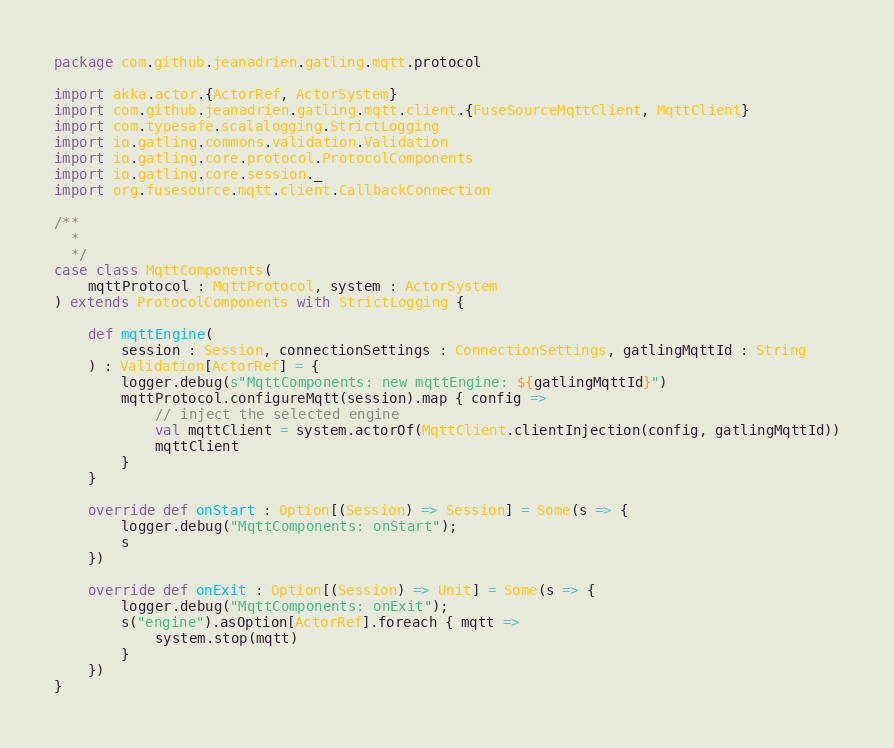<code> <loc_0><loc_0><loc_500><loc_500><_Scala_>package com.github.jeanadrien.gatling.mqtt.protocol

import akka.actor.{ActorRef, ActorSystem}
import com.github.jeanadrien.gatling.mqtt.client.{FuseSourceMqttClient, MqttClient}
import com.typesafe.scalalogging.StrictLogging
import io.gatling.commons.validation.Validation
import io.gatling.core.protocol.ProtocolComponents
import io.gatling.core.session._
import org.fusesource.mqtt.client.CallbackConnection

/**
  *
  */
case class MqttComponents(
    mqttProtocol : MqttProtocol, system : ActorSystem
) extends ProtocolComponents with StrictLogging {

    def mqttEngine(
        session : Session, connectionSettings : ConnectionSettings, gatlingMqttId : String
    ) : Validation[ActorRef] = {
        logger.debug(s"MqttComponents: new mqttEngine: ${gatlingMqttId}")
        mqttProtocol.configureMqtt(session).map { config =>
            // inject the selected engine
            val mqttClient = system.actorOf(MqttClient.clientInjection(config, gatlingMqttId))
            mqttClient
        }
    }

    override def onStart : Option[(Session) => Session] = Some(s => {
        logger.debug("MqttComponents: onStart");
        s
    })

    override def onExit : Option[(Session) => Unit] = Some(s => {
        logger.debug("MqttComponents: onExit");
        s("engine").asOption[ActorRef].foreach { mqtt =>
            system.stop(mqtt)
        }
    })
}
</code> 